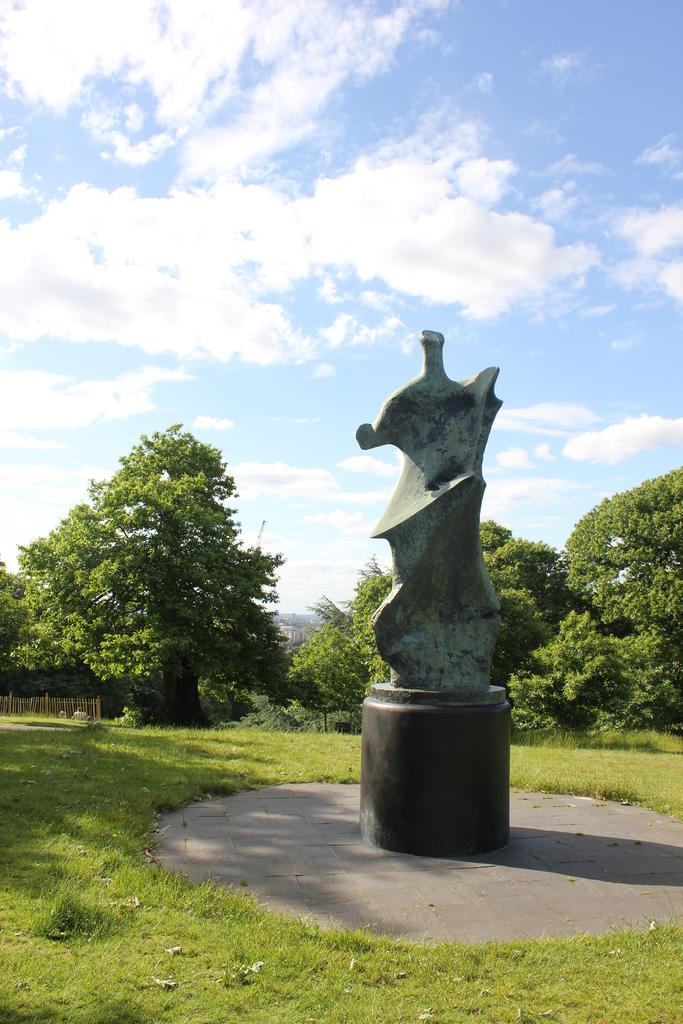What type of vegetation is visible in the front of the image? There is grass in the front of the image. What is the main subject in the center of the image? There is a structure in the center of the image. What can be seen in the background of the image? There are trees in the background of the image. How would you describe the sky in the image? The sky is cloudy in the image. How many divisions of the key can be seen in the image? There is no key present in the image, so it is not possible to determine the number of divisions. 